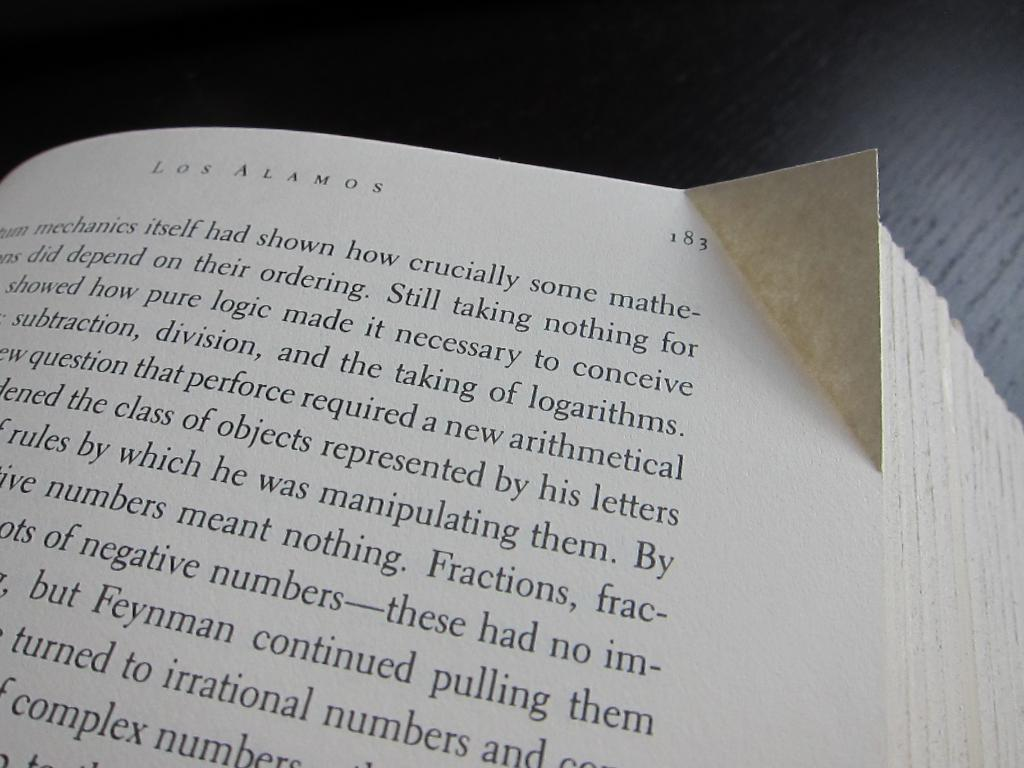<image>
Offer a succinct explanation of the picture presented. Book with a creased side on page 183. 